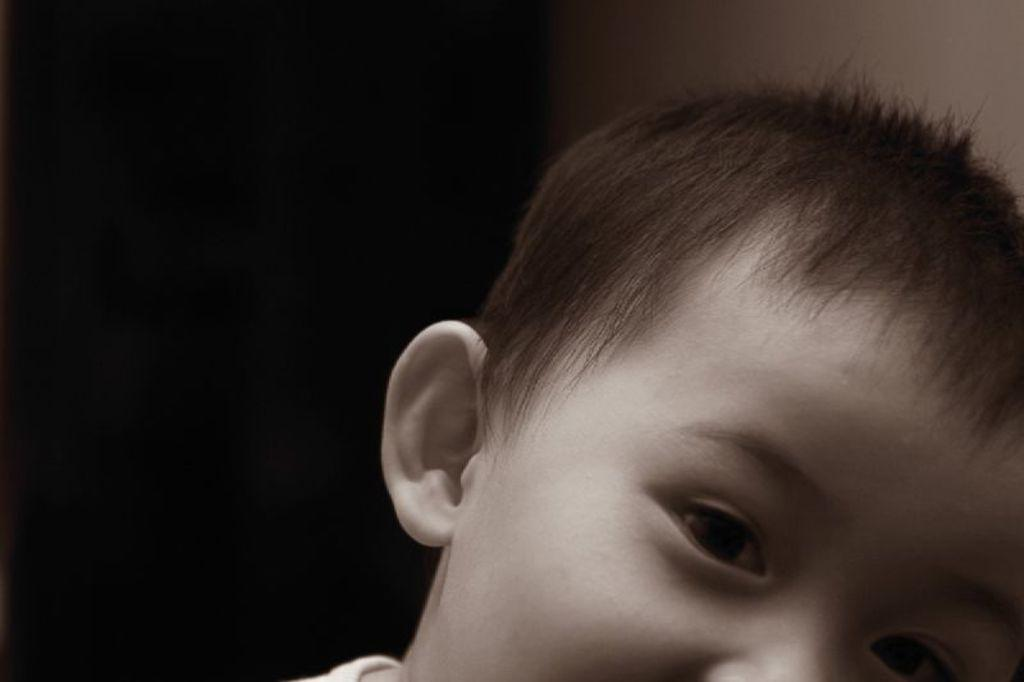What is the main subject in the foreground of the image? There is a boy in the foreground of the image. What is the color scheme of the background in the image? The background of the image is black and white. What type of crow is sitting on the boy's shoulder in the image? There is no crow present in the image; it only features a boy in the foreground and a black and white background. 